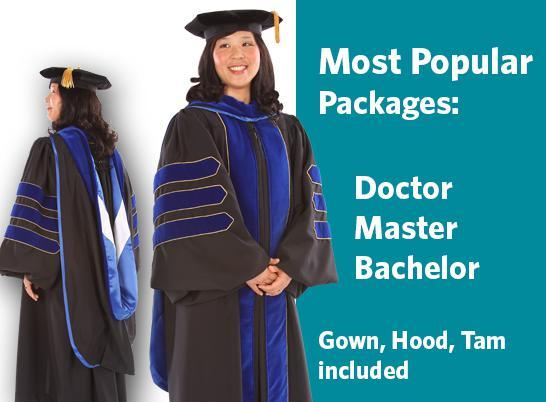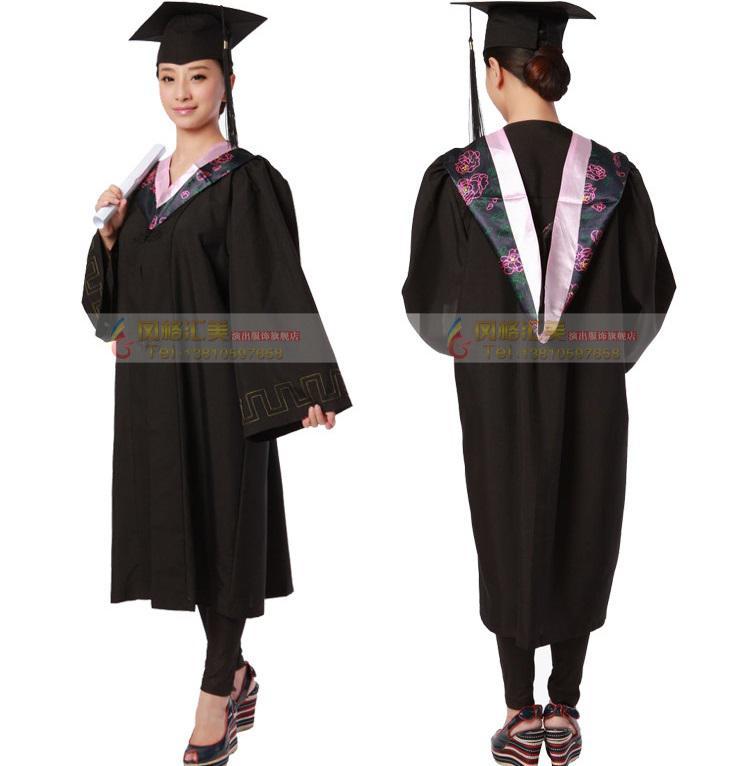The first image is the image on the left, the second image is the image on the right. Analyze the images presented: Is the assertion "At least one image shows only a female graduate." valid? Answer yes or no. Yes. The first image is the image on the left, the second image is the image on the right. Evaluate the accuracy of this statement regarding the images: "All graduation gown models are one gender.". Is it true? Answer yes or no. Yes. 